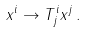Convert formula to latex. <formula><loc_0><loc_0><loc_500><loc_500>x ^ { i } \rightarrow T ^ { i } _ { j } x ^ { j } \, .</formula> 